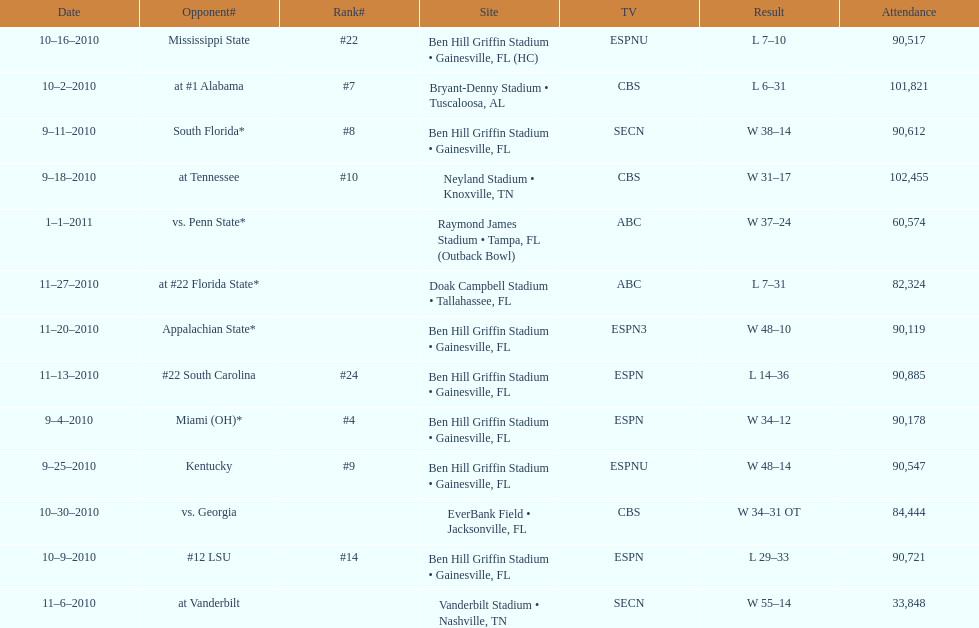What was the difference between the two scores of the last game? 13 points. 